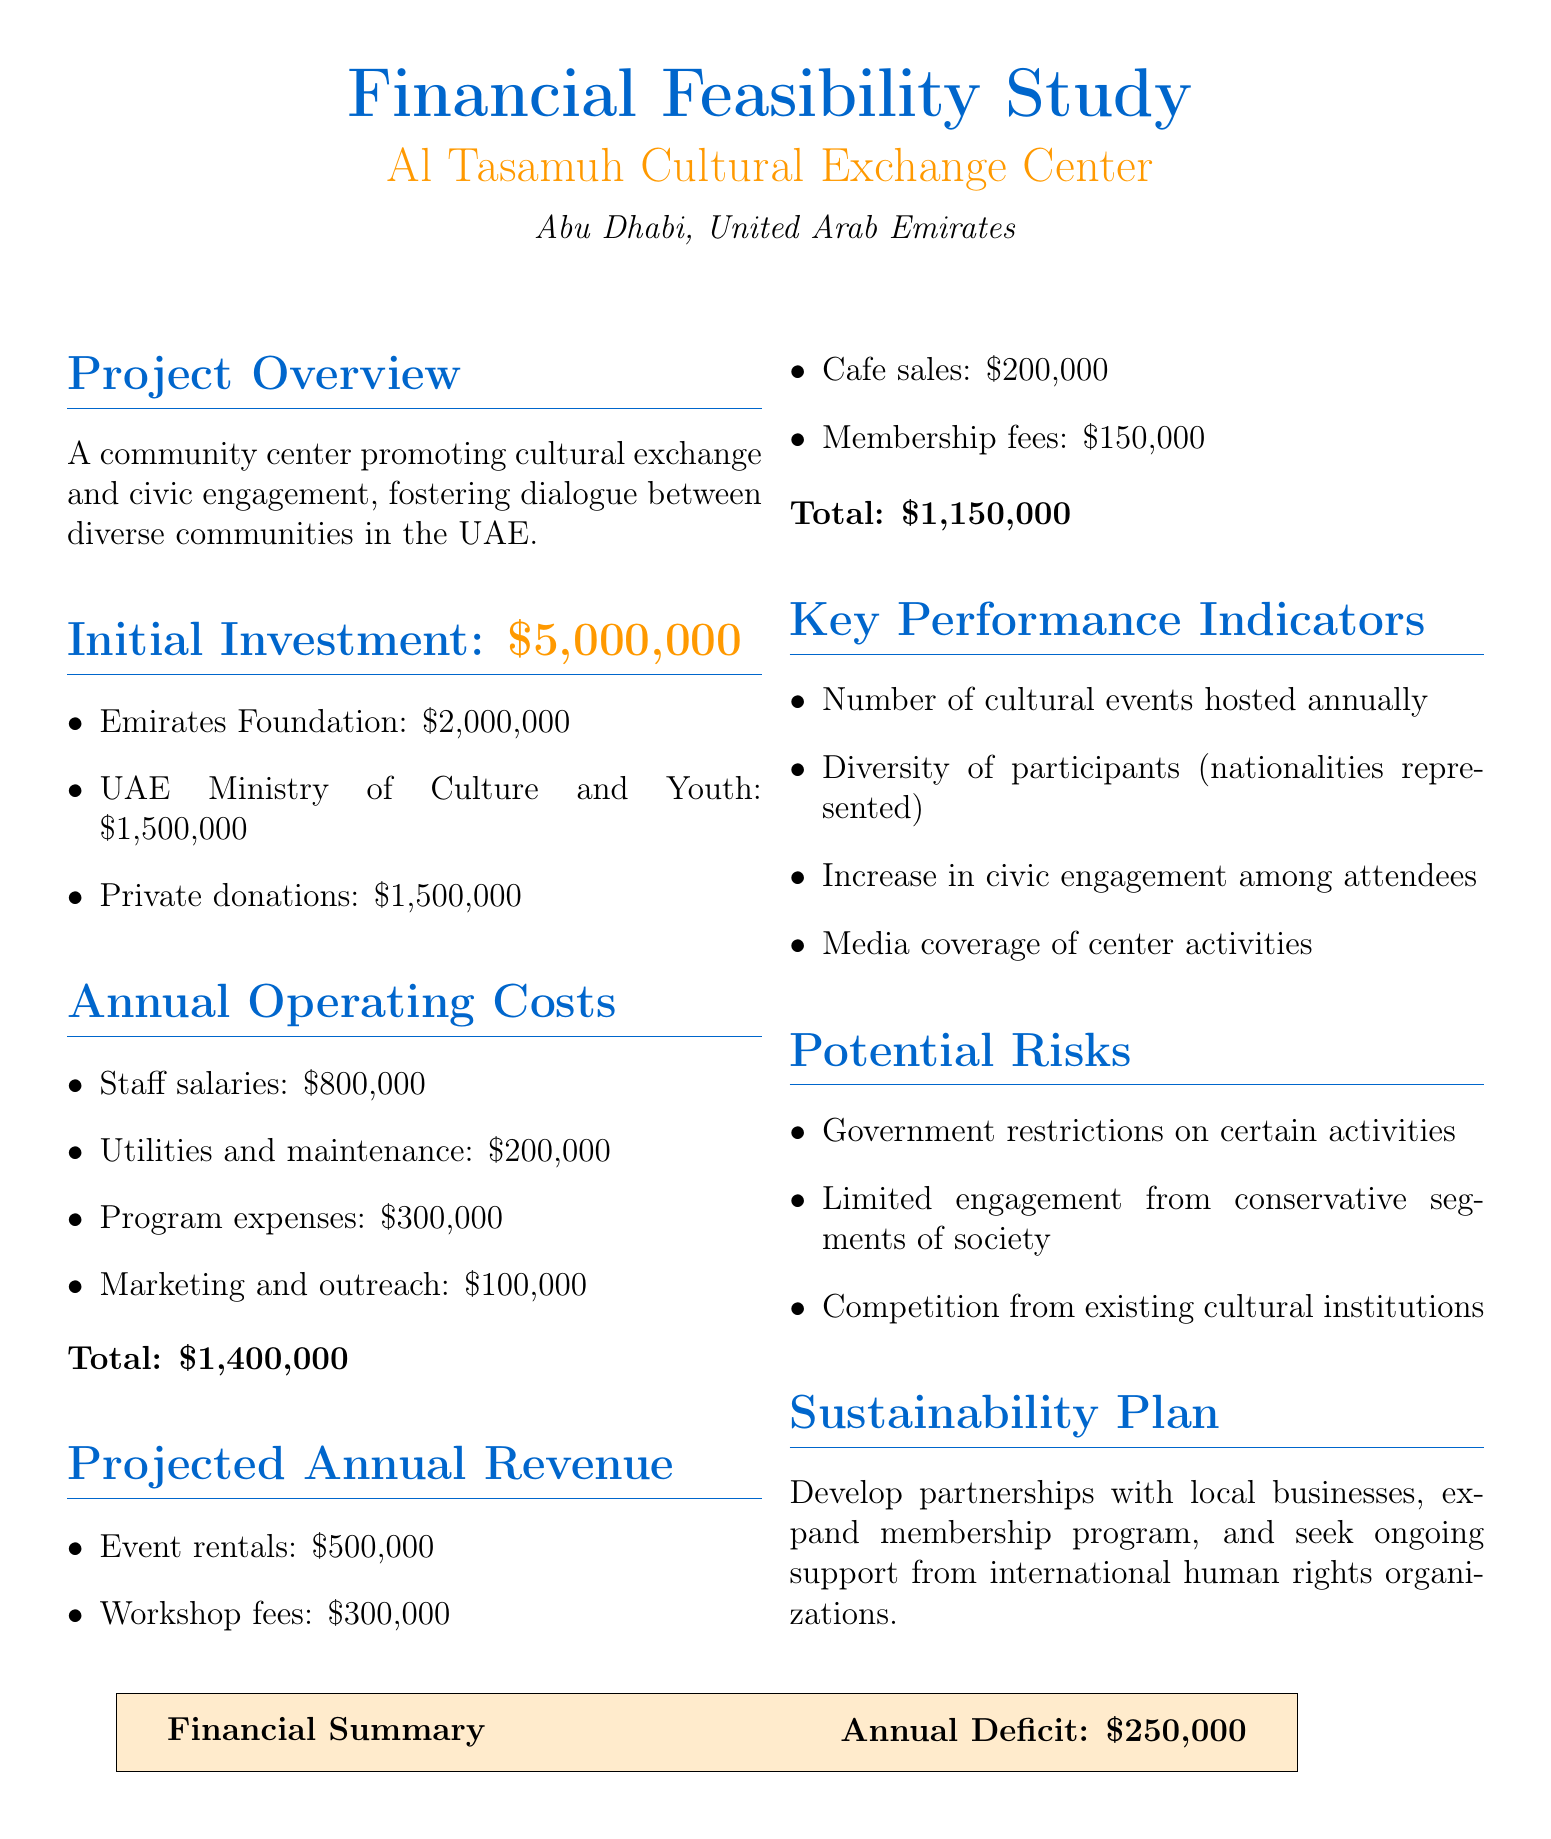what is the project name? The project name is mentioned at the beginning of the document as "Al Tasamuh Cultural Exchange Center."
Answer: Al Tasamuh Cultural Exchange Center what is the initial investment amount? The document specifies the initial investment needed for the project, which is $5,000,000.
Answer: $5,000,000 who is one of the funding sources? The document lists several funding sources, including the "Emirates Foundation."
Answer: Emirates Foundation what are the annual operating costs? The total annual operating costs are calculated by adding all the individual expense categories, which amount to $1,400,000.
Answer: $1,400,000 what is the projected annual revenue? The document outlines the total projected annual revenue of the center as $1,150,000.
Answer: $1,150,000 what is a potential risk mentioned in the document? The document states several potential risks, one of which is "Government restrictions on certain activities."
Answer: Government restrictions on certain activities how does the center plan to achieve sustainability? The sustainability plan outlined in the document includes developing partnerships with local businesses and expanding the membership program.
Answer: Develop partnerships with local businesses what is one of the key performance indicators? The document includes the "Number of cultural events hosted annually" as a key performance indicator.
Answer: Number of cultural events hosted annually what is the annual deficit? The financial summary at the end of the document states that the annual deficit is $250,000.
Answer: $250,000 